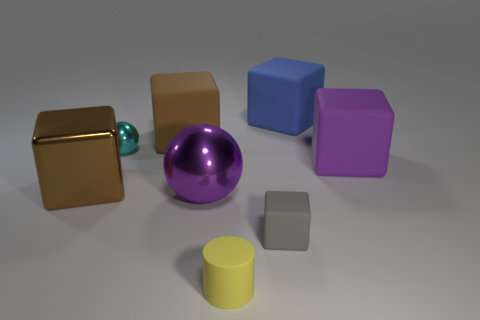Subtract all blue blocks. How many blocks are left? 4 Subtract all green cubes. Subtract all red spheres. How many cubes are left? 5 Add 2 metallic cubes. How many objects exist? 10 Subtract all cylinders. How many objects are left? 7 Subtract 0 green cylinders. How many objects are left? 8 Subtract all big cyan rubber spheres. Subtract all big blue rubber blocks. How many objects are left? 7 Add 8 tiny cyan shiny things. How many tiny cyan shiny things are left? 9 Add 6 gray metallic spheres. How many gray metallic spheres exist? 6 